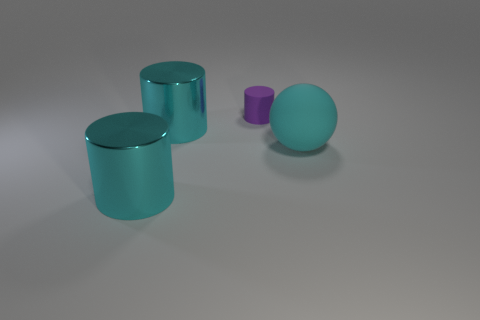How many other objects are the same material as the small purple thing?
Give a very brief answer. 1. There is a thing that is both in front of the purple matte cylinder and behind the large rubber ball; what is its shape?
Your answer should be very brief. Cylinder. There is a matte thing in front of the purple matte cylinder; is it the same size as the cyan metal cylinder that is in front of the cyan matte thing?
Provide a succinct answer. Yes. There is a thing that is the same material as the small cylinder; what is its shape?
Offer a very short reply. Sphere. Is there any other thing that is the same shape as the small matte thing?
Ensure brevity in your answer.  Yes. The thing that is on the right side of the matte object behind the cyan thing that is behind the large cyan rubber ball is what color?
Make the answer very short. Cyan. Is the number of big cyan cylinders that are on the right side of the tiny purple matte cylinder less than the number of large cyan cylinders on the right side of the ball?
Offer a terse response. No. Does the tiny purple rubber thing have the same shape as the big cyan rubber thing?
Offer a very short reply. No. How many cyan matte balls have the same size as the purple object?
Offer a terse response. 0. Is the number of large cyan metal cylinders on the right side of the rubber ball less than the number of big balls?
Make the answer very short. Yes. 